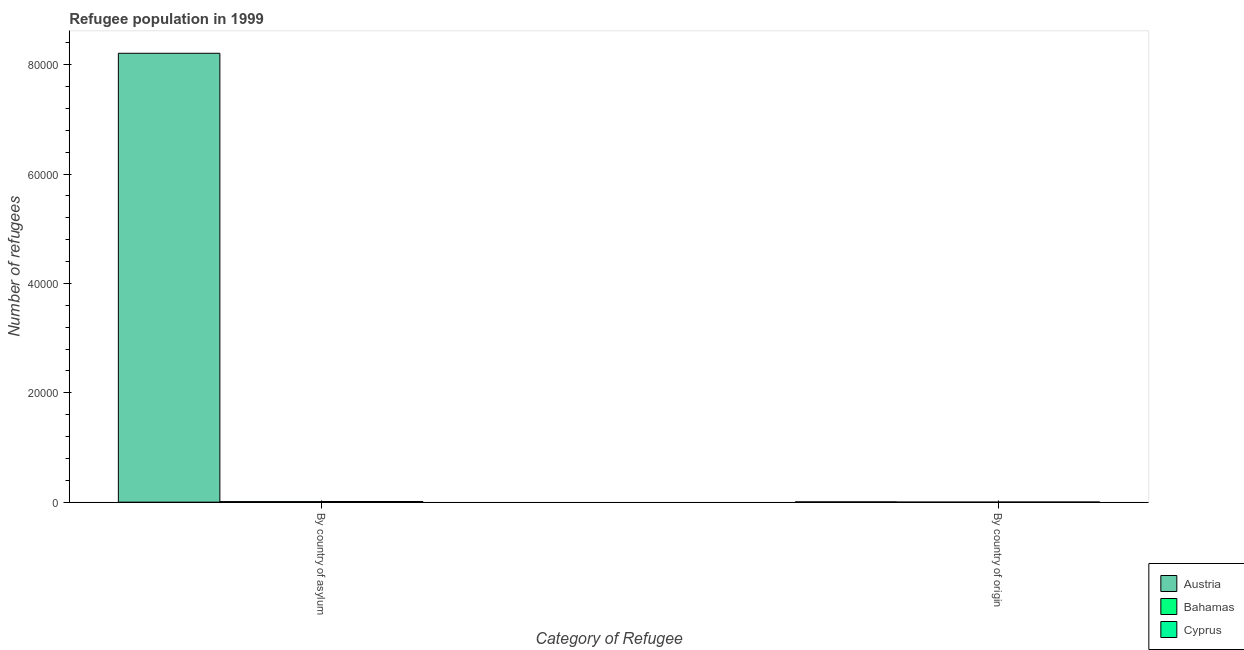How many different coloured bars are there?
Offer a very short reply. 3. How many groups of bars are there?
Your answer should be very brief. 2. Are the number of bars per tick equal to the number of legend labels?
Your answer should be compact. Yes. Are the number of bars on each tick of the X-axis equal?
Ensure brevity in your answer.  Yes. What is the label of the 1st group of bars from the left?
Your response must be concise. By country of asylum. What is the number of refugees by country of origin in Cyprus?
Offer a terse response. 16. Across all countries, what is the maximum number of refugees by country of origin?
Your answer should be compact. 48. Across all countries, what is the minimum number of refugees by country of origin?
Give a very brief answer. 1. In which country was the number of refugees by country of origin maximum?
Your answer should be very brief. Austria. In which country was the number of refugees by country of asylum minimum?
Your answer should be very brief. Bahamas. What is the total number of refugees by country of asylum in the graph?
Give a very brief answer. 8.23e+04. What is the difference between the number of refugees by country of origin in Cyprus and that in Austria?
Offer a very short reply. -32. What is the difference between the number of refugees by country of asylum in Cyprus and the number of refugees by country of origin in Austria?
Provide a short and direct response. 69. What is the average number of refugees by country of origin per country?
Your response must be concise. 21.67. What is the difference between the number of refugees by country of origin and number of refugees by country of asylum in Bahamas?
Your response must be concise. -99. What does the 2nd bar from the left in By country of origin represents?
Make the answer very short. Bahamas. How many countries are there in the graph?
Offer a very short reply. 3. Does the graph contain grids?
Give a very brief answer. No. Where does the legend appear in the graph?
Offer a very short reply. Bottom right. How many legend labels are there?
Provide a short and direct response. 3. How are the legend labels stacked?
Give a very brief answer. Vertical. What is the title of the graph?
Your answer should be compact. Refugee population in 1999. Does "Cuba" appear as one of the legend labels in the graph?
Ensure brevity in your answer.  No. What is the label or title of the X-axis?
Make the answer very short. Category of Refugee. What is the label or title of the Y-axis?
Provide a succinct answer. Number of refugees. What is the Number of refugees in Austria in By country of asylum?
Make the answer very short. 8.21e+04. What is the Number of refugees in Bahamas in By country of asylum?
Your answer should be very brief. 100. What is the Number of refugees of Cyprus in By country of asylum?
Give a very brief answer. 117. Across all Category of Refugee, what is the maximum Number of refugees in Austria?
Give a very brief answer. 8.21e+04. Across all Category of Refugee, what is the maximum Number of refugees of Bahamas?
Keep it short and to the point. 100. Across all Category of Refugee, what is the maximum Number of refugees of Cyprus?
Give a very brief answer. 117. Across all Category of Refugee, what is the minimum Number of refugees in Austria?
Give a very brief answer. 48. What is the total Number of refugees in Austria in the graph?
Make the answer very short. 8.21e+04. What is the total Number of refugees in Bahamas in the graph?
Offer a terse response. 101. What is the total Number of refugees of Cyprus in the graph?
Your response must be concise. 133. What is the difference between the Number of refugees in Austria in By country of asylum and that in By country of origin?
Ensure brevity in your answer.  8.20e+04. What is the difference between the Number of refugees of Cyprus in By country of asylum and that in By country of origin?
Keep it short and to the point. 101. What is the difference between the Number of refugees in Austria in By country of asylum and the Number of refugees in Bahamas in By country of origin?
Your answer should be compact. 8.21e+04. What is the difference between the Number of refugees in Austria in By country of asylum and the Number of refugees in Cyprus in By country of origin?
Give a very brief answer. 8.21e+04. What is the difference between the Number of refugees of Bahamas in By country of asylum and the Number of refugees of Cyprus in By country of origin?
Give a very brief answer. 84. What is the average Number of refugees in Austria per Category of Refugee?
Provide a succinct answer. 4.11e+04. What is the average Number of refugees in Bahamas per Category of Refugee?
Your answer should be compact. 50.5. What is the average Number of refugees in Cyprus per Category of Refugee?
Provide a short and direct response. 66.5. What is the difference between the Number of refugees of Austria and Number of refugees of Bahamas in By country of asylum?
Provide a succinct answer. 8.20e+04. What is the difference between the Number of refugees in Austria and Number of refugees in Cyprus in By country of asylum?
Provide a short and direct response. 8.20e+04. What is the difference between the Number of refugees in Bahamas and Number of refugees in Cyprus in By country of asylum?
Offer a very short reply. -17. What is the difference between the Number of refugees of Austria and Number of refugees of Bahamas in By country of origin?
Ensure brevity in your answer.  47. What is the difference between the Number of refugees of Austria and Number of refugees of Cyprus in By country of origin?
Ensure brevity in your answer.  32. What is the difference between the Number of refugees in Bahamas and Number of refugees in Cyprus in By country of origin?
Keep it short and to the point. -15. What is the ratio of the Number of refugees of Austria in By country of asylum to that in By country of origin?
Offer a terse response. 1710.02. What is the ratio of the Number of refugees in Bahamas in By country of asylum to that in By country of origin?
Your answer should be very brief. 100. What is the ratio of the Number of refugees in Cyprus in By country of asylum to that in By country of origin?
Provide a succinct answer. 7.31. What is the difference between the highest and the second highest Number of refugees of Austria?
Provide a short and direct response. 8.20e+04. What is the difference between the highest and the second highest Number of refugees of Cyprus?
Provide a short and direct response. 101. What is the difference between the highest and the lowest Number of refugees of Austria?
Offer a very short reply. 8.20e+04. What is the difference between the highest and the lowest Number of refugees of Bahamas?
Offer a very short reply. 99. What is the difference between the highest and the lowest Number of refugees of Cyprus?
Give a very brief answer. 101. 